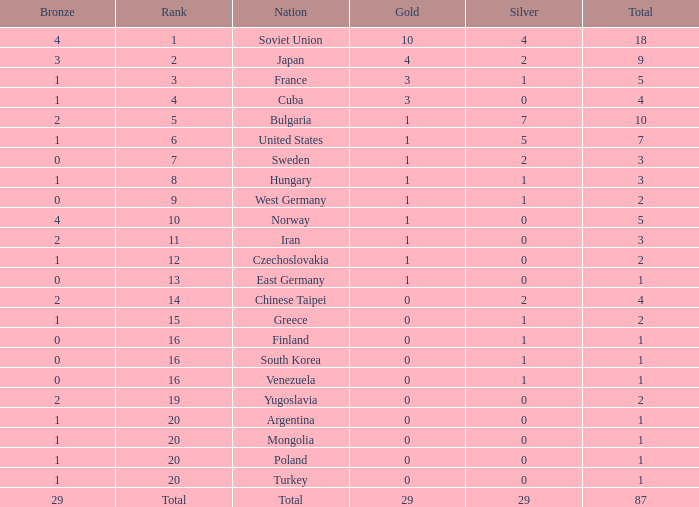What is the average number of bronze medals for total of all nations? 29.0. 